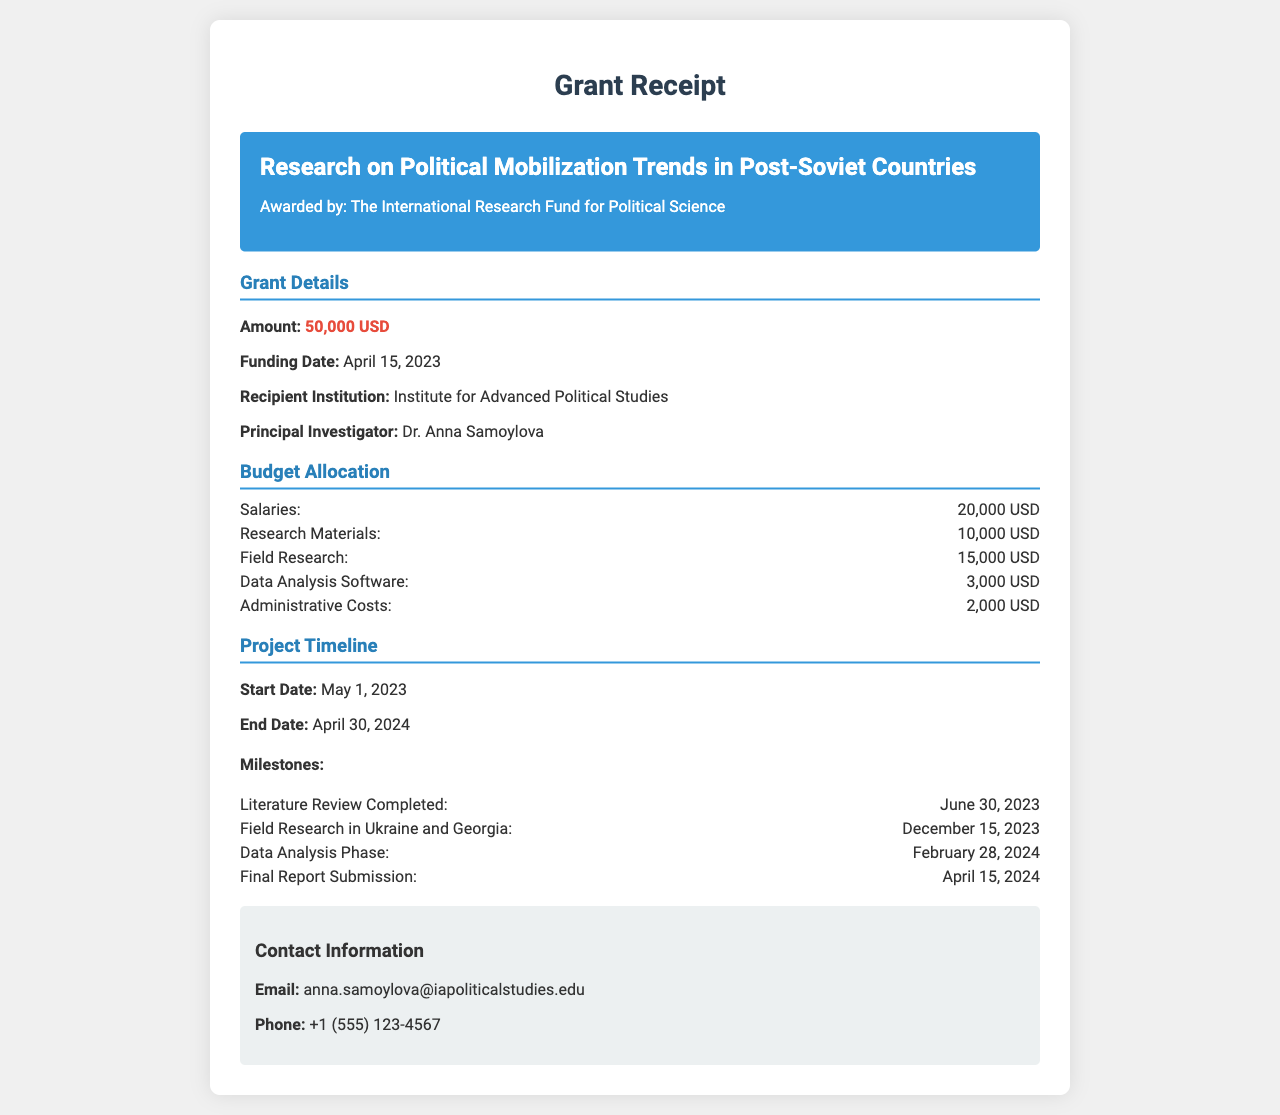what is the grant amount? The grant amount is specified in the document as 50,000 USD.
Answer: 50,000 USD who is the principal investigator? The principal investigator is mentioned in the document as Dr. Anna Samoylova.
Answer: Dr. Anna Samoylova when was the funding date? The funding date is listed in the document as April 15, 2023.
Answer: April 15, 2023 what is the end date of the project? The document states the project end date as April 30, 2024.
Answer: April 30, 2024 how much is allocated for field research? The document specifies that 15,000 USD is allocated for field research.
Answer: 15,000 USD what milestone is scheduled for February 28, 2024? The document indicates that the Data Analysis Phase is scheduled for February 28, 2024.
Answer: Data Analysis Phase which countries will the field research occur? The document mentions that field research will take place in Ukraine and Georgia.
Answer: Ukraine and Georgia what is the total amount allocated for research materials and data analysis software? The total amount is calculated by adding 10,000 USD for research materials and 3,000 USD for data analysis software, resulting in 13,000 USD.
Answer: 13,000 USD what is the recipient institution? The recipient institution is stated in the document as Institute for Advanced Political Studies.
Answer: Institute for Advanced Political Studies 